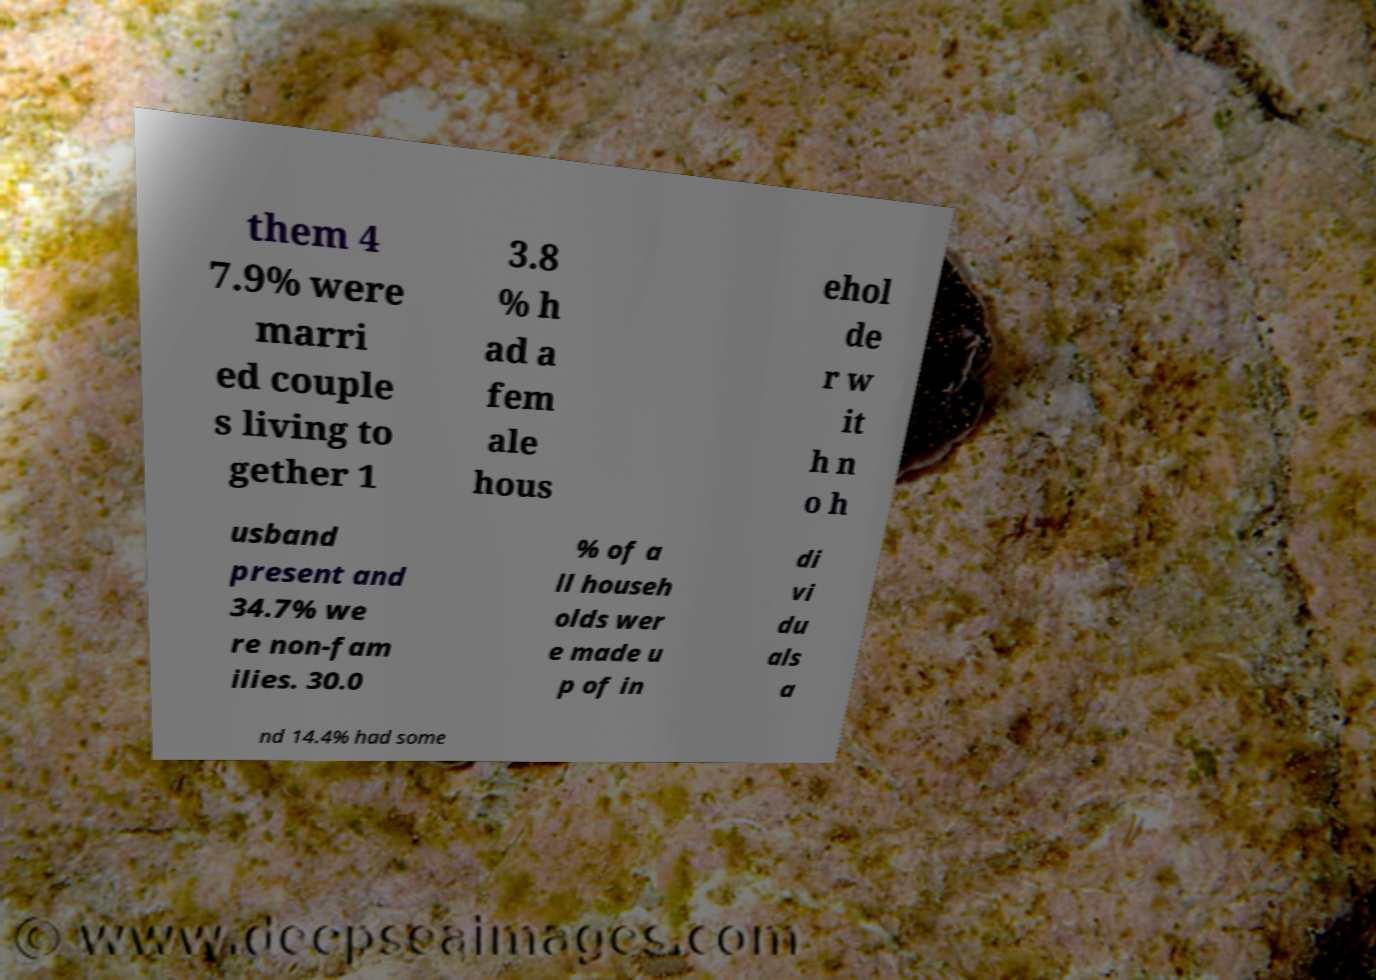Could you extract and type out the text from this image? them 4 7.9% were marri ed couple s living to gether 1 3.8 % h ad a fem ale hous ehol de r w it h n o h usband present and 34.7% we re non-fam ilies. 30.0 % of a ll househ olds wer e made u p of in di vi du als a nd 14.4% had some 